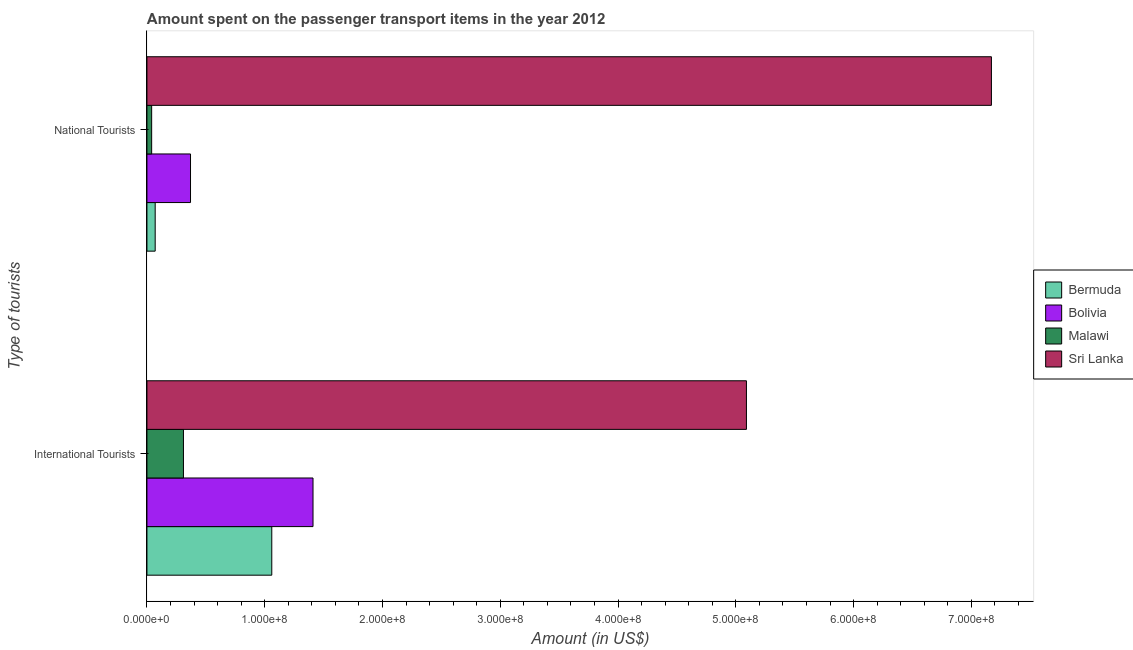How many groups of bars are there?
Ensure brevity in your answer.  2. Are the number of bars per tick equal to the number of legend labels?
Offer a very short reply. Yes. How many bars are there on the 2nd tick from the bottom?
Keep it short and to the point. 4. What is the label of the 1st group of bars from the top?
Make the answer very short. National Tourists. What is the amount spent on transport items of national tourists in Bermuda?
Keep it short and to the point. 7.00e+06. Across all countries, what is the maximum amount spent on transport items of international tourists?
Provide a succinct answer. 5.09e+08. Across all countries, what is the minimum amount spent on transport items of national tourists?
Offer a very short reply. 4.00e+06. In which country was the amount spent on transport items of national tourists maximum?
Keep it short and to the point. Sri Lanka. In which country was the amount spent on transport items of national tourists minimum?
Keep it short and to the point. Malawi. What is the total amount spent on transport items of international tourists in the graph?
Offer a terse response. 7.87e+08. What is the difference between the amount spent on transport items of international tourists in Malawi and that in Sri Lanka?
Offer a very short reply. -4.78e+08. What is the difference between the amount spent on transport items of international tourists in Bermuda and the amount spent on transport items of national tourists in Bolivia?
Make the answer very short. 6.90e+07. What is the average amount spent on transport items of international tourists per country?
Make the answer very short. 1.97e+08. What is the difference between the amount spent on transport items of international tourists and amount spent on transport items of national tourists in Malawi?
Give a very brief answer. 2.70e+07. What is the ratio of the amount spent on transport items of international tourists in Bolivia to that in Sri Lanka?
Offer a terse response. 0.28. In how many countries, is the amount spent on transport items of national tourists greater than the average amount spent on transport items of national tourists taken over all countries?
Keep it short and to the point. 1. What does the 4th bar from the top in National Tourists represents?
Your answer should be compact. Bermuda. What does the 1st bar from the bottom in International Tourists represents?
Offer a terse response. Bermuda. Are all the bars in the graph horizontal?
Provide a short and direct response. Yes. Are the values on the major ticks of X-axis written in scientific E-notation?
Provide a short and direct response. Yes. What is the title of the graph?
Provide a succinct answer. Amount spent on the passenger transport items in the year 2012. What is the label or title of the X-axis?
Your answer should be compact. Amount (in US$). What is the label or title of the Y-axis?
Provide a succinct answer. Type of tourists. What is the Amount (in US$) in Bermuda in International Tourists?
Ensure brevity in your answer.  1.06e+08. What is the Amount (in US$) in Bolivia in International Tourists?
Your response must be concise. 1.41e+08. What is the Amount (in US$) of Malawi in International Tourists?
Make the answer very short. 3.10e+07. What is the Amount (in US$) of Sri Lanka in International Tourists?
Give a very brief answer. 5.09e+08. What is the Amount (in US$) of Bermuda in National Tourists?
Provide a succinct answer. 7.00e+06. What is the Amount (in US$) of Bolivia in National Tourists?
Provide a short and direct response. 3.70e+07. What is the Amount (in US$) of Sri Lanka in National Tourists?
Give a very brief answer. 7.17e+08. Across all Type of tourists, what is the maximum Amount (in US$) of Bermuda?
Keep it short and to the point. 1.06e+08. Across all Type of tourists, what is the maximum Amount (in US$) in Bolivia?
Provide a succinct answer. 1.41e+08. Across all Type of tourists, what is the maximum Amount (in US$) in Malawi?
Make the answer very short. 3.10e+07. Across all Type of tourists, what is the maximum Amount (in US$) of Sri Lanka?
Your answer should be very brief. 7.17e+08. Across all Type of tourists, what is the minimum Amount (in US$) of Bermuda?
Keep it short and to the point. 7.00e+06. Across all Type of tourists, what is the minimum Amount (in US$) of Bolivia?
Offer a very short reply. 3.70e+07. Across all Type of tourists, what is the minimum Amount (in US$) of Malawi?
Ensure brevity in your answer.  4.00e+06. Across all Type of tourists, what is the minimum Amount (in US$) of Sri Lanka?
Provide a short and direct response. 5.09e+08. What is the total Amount (in US$) in Bermuda in the graph?
Your answer should be compact. 1.13e+08. What is the total Amount (in US$) of Bolivia in the graph?
Your response must be concise. 1.78e+08. What is the total Amount (in US$) in Malawi in the graph?
Offer a very short reply. 3.50e+07. What is the total Amount (in US$) of Sri Lanka in the graph?
Ensure brevity in your answer.  1.23e+09. What is the difference between the Amount (in US$) of Bermuda in International Tourists and that in National Tourists?
Offer a terse response. 9.90e+07. What is the difference between the Amount (in US$) in Bolivia in International Tourists and that in National Tourists?
Make the answer very short. 1.04e+08. What is the difference between the Amount (in US$) in Malawi in International Tourists and that in National Tourists?
Your answer should be very brief. 2.70e+07. What is the difference between the Amount (in US$) in Sri Lanka in International Tourists and that in National Tourists?
Provide a short and direct response. -2.08e+08. What is the difference between the Amount (in US$) of Bermuda in International Tourists and the Amount (in US$) of Bolivia in National Tourists?
Your answer should be very brief. 6.90e+07. What is the difference between the Amount (in US$) in Bermuda in International Tourists and the Amount (in US$) in Malawi in National Tourists?
Make the answer very short. 1.02e+08. What is the difference between the Amount (in US$) in Bermuda in International Tourists and the Amount (in US$) in Sri Lanka in National Tourists?
Offer a very short reply. -6.11e+08. What is the difference between the Amount (in US$) in Bolivia in International Tourists and the Amount (in US$) in Malawi in National Tourists?
Provide a short and direct response. 1.37e+08. What is the difference between the Amount (in US$) in Bolivia in International Tourists and the Amount (in US$) in Sri Lanka in National Tourists?
Make the answer very short. -5.76e+08. What is the difference between the Amount (in US$) in Malawi in International Tourists and the Amount (in US$) in Sri Lanka in National Tourists?
Give a very brief answer. -6.86e+08. What is the average Amount (in US$) in Bermuda per Type of tourists?
Provide a succinct answer. 5.65e+07. What is the average Amount (in US$) of Bolivia per Type of tourists?
Your response must be concise. 8.90e+07. What is the average Amount (in US$) in Malawi per Type of tourists?
Your response must be concise. 1.75e+07. What is the average Amount (in US$) of Sri Lanka per Type of tourists?
Ensure brevity in your answer.  6.13e+08. What is the difference between the Amount (in US$) in Bermuda and Amount (in US$) in Bolivia in International Tourists?
Give a very brief answer. -3.50e+07. What is the difference between the Amount (in US$) in Bermuda and Amount (in US$) in Malawi in International Tourists?
Your answer should be very brief. 7.50e+07. What is the difference between the Amount (in US$) of Bermuda and Amount (in US$) of Sri Lanka in International Tourists?
Ensure brevity in your answer.  -4.03e+08. What is the difference between the Amount (in US$) in Bolivia and Amount (in US$) in Malawi in International Tourists?
Offer a very short reply. 1.10e+08. What is the difference between the Amount (in US$) in Bolivia and Amount (in US$) in Sri Lanka in International Tourists?
Your answer should be very brief. -3.68e+08. What is the difference between the Amount (in US$) of Malawi and Amount (in US$) of Sri Lanka in International Tourists?
Provide a succinct answer. -4.78e+08. What is the difference between the Amount (in US$) in Bermuda and Amount (in US$) in Bolivia in National Tourists?
Provide a succinct answer. -3.00e+07. What is the difference between the Amount (in US$) in Bermuda and Amount (in US$) in Sri Lanka in National Tourists?
Your answer should be very brief. -7.10e+08. What is the difference between the Amount (in US$) of Bolivia and Amount (in US$) of Malawi in National Tourists?
Your response must be concise. 3.30e+07. What is the difference between the Amount (in US$) of Bolivia and Amount (in US$) of Sri Lanka in National Tourists?
Provide a short and direct response. -6.80e+08. What is the difference between the Amount (in US$) of Malawi and Amount (in US$) of Sri Lanka in National Tourists?
Offer a very short reply. -7.13e+08. What is the ratio of the Amount (in US$) of Bermuda in International Tourists to that in National Tourists?
Give a very brief answer. 15.14. What is the ratio of the Amount (in US$) of Bolivia in International Tourists to that in National Tourists?
Your response must be concise. 3.81. What is the ratio of the Amount (in US$) of Malawi in International Tourists to that in National Tourists?
Give a very brief answer. 7.75. What is the ratio of the Amount (in US$) in Sri Lanka in International Tourists to that in National Tourists?
Provide a succinct answer. 0.71. What is the difference between the highest and the second highest Amount (in US$) of Bermuda?
Keep it short and to the point. 9.90e+07. What is the difference between the highest and the second highest Amount (in US$) in Bolivia?
Ensure brevity in your answer.  1.04e+08. What is the difference between the highest and the second highest Amount (in US$) of Malawi?
Provide a succinct answer. 2.70e+07. What is the difference between the highest and the second highest Amount (in US$) of Sri Lanka?
Your answer should be very brief. 2.08e+08. What is the difference between the highest and the lowest Amount (in US$) in Bermuda?
Provide a succinct answer. 9.90e+07. What is the difference between the highest and the lowest Amount (in US$) in Bolivia?
Offer a very short reply. 1.04e+08. What is the difference between the highest and the lowest Amount (in US$) in Malawi?
Ensure brevity in your answer.  2.70e+07. What is the difference between the highest and the lowest Amount (in US$) of Sri Lanka?
Offer a terse response. 2.08e+08. 